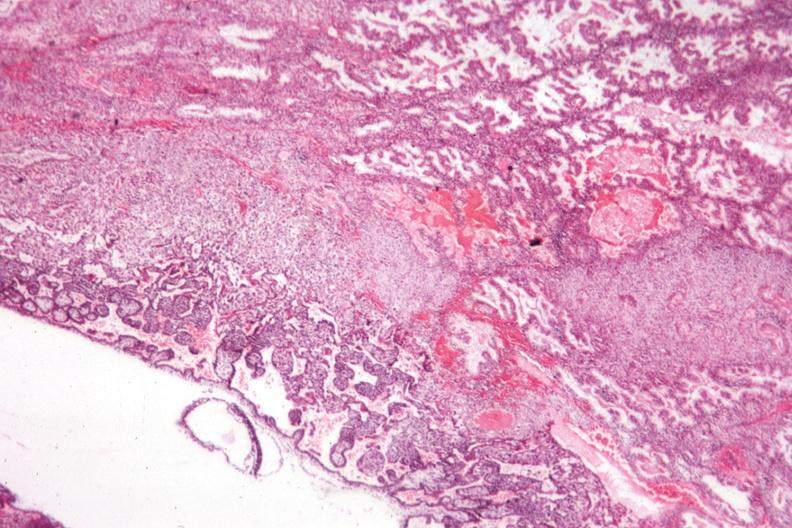where is this from?
Answer the question using a single word or phrase. Female reproductive system 